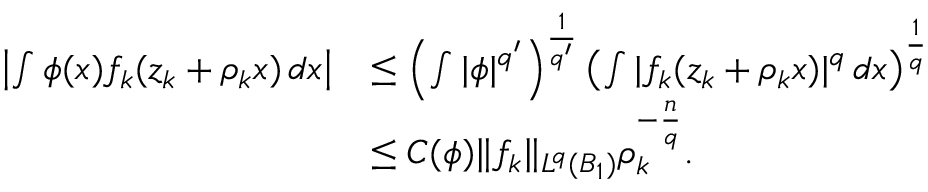Convert formula to latex. <formula><loc_0><loc_0><loc_500><loc_500>\begin{array} { r l } { \left | \int \phi ( x ) f _ { k } ( z _ { k } + \rho _ { k } x ) \, d x \right | } & { \leq \left ( \int | \phi | ^ { q ^ { \prime } } \right ) ^ { \frac { 1 } { q ^ { \prime } } } \left ( \int | f _ { k } ( z _ { k } + \rho _ { k } x ) | ^ { q } \, d x \right ) ^ { \frac { 1 } { q } } } \\ & { \leq C ( \phi ) \| f _ { k } \| _ { L ^ { q } ( B _ { 1 } ) } \rho _ { k } ^ { - \frac { n } { q } } . } \end{array}</formula> 